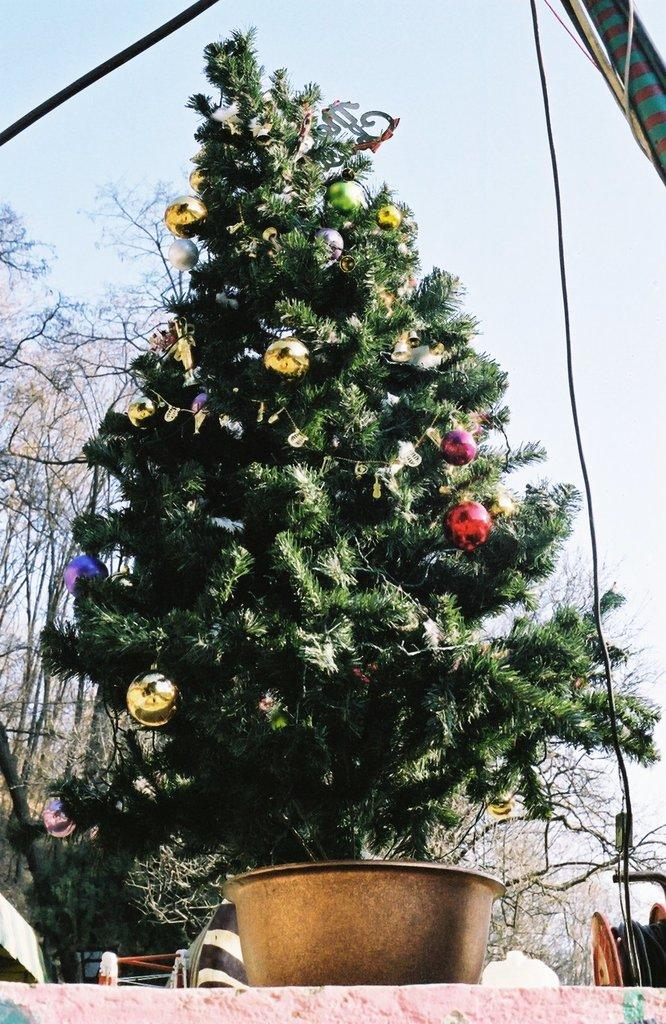What is the main subject of the image? There is a Christmas tree in the image. How is the Christmas tree decorated? The Christmas tree is decorated with balls. What can be seen in the background of the image? There are trees visible in the background of the image. What is visible at the top of the image? The sky is visible at the top of the image. What type of jam is spread on the bridge in the image? There is no jam or bridge present in the image; it features a Christmas tree decorated with balls. 